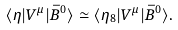Convert formula to latex. <formula><loc_0><loc_0><loc_500><loc_500>\langle \eta | V ^ { \mu } | \bar { B } ^ { 0 } \rangle \simeq \langle \eta _ { 8 } | V ^ { \mu } | \bar { B } ^ { 0 } \rangle .</formula> 